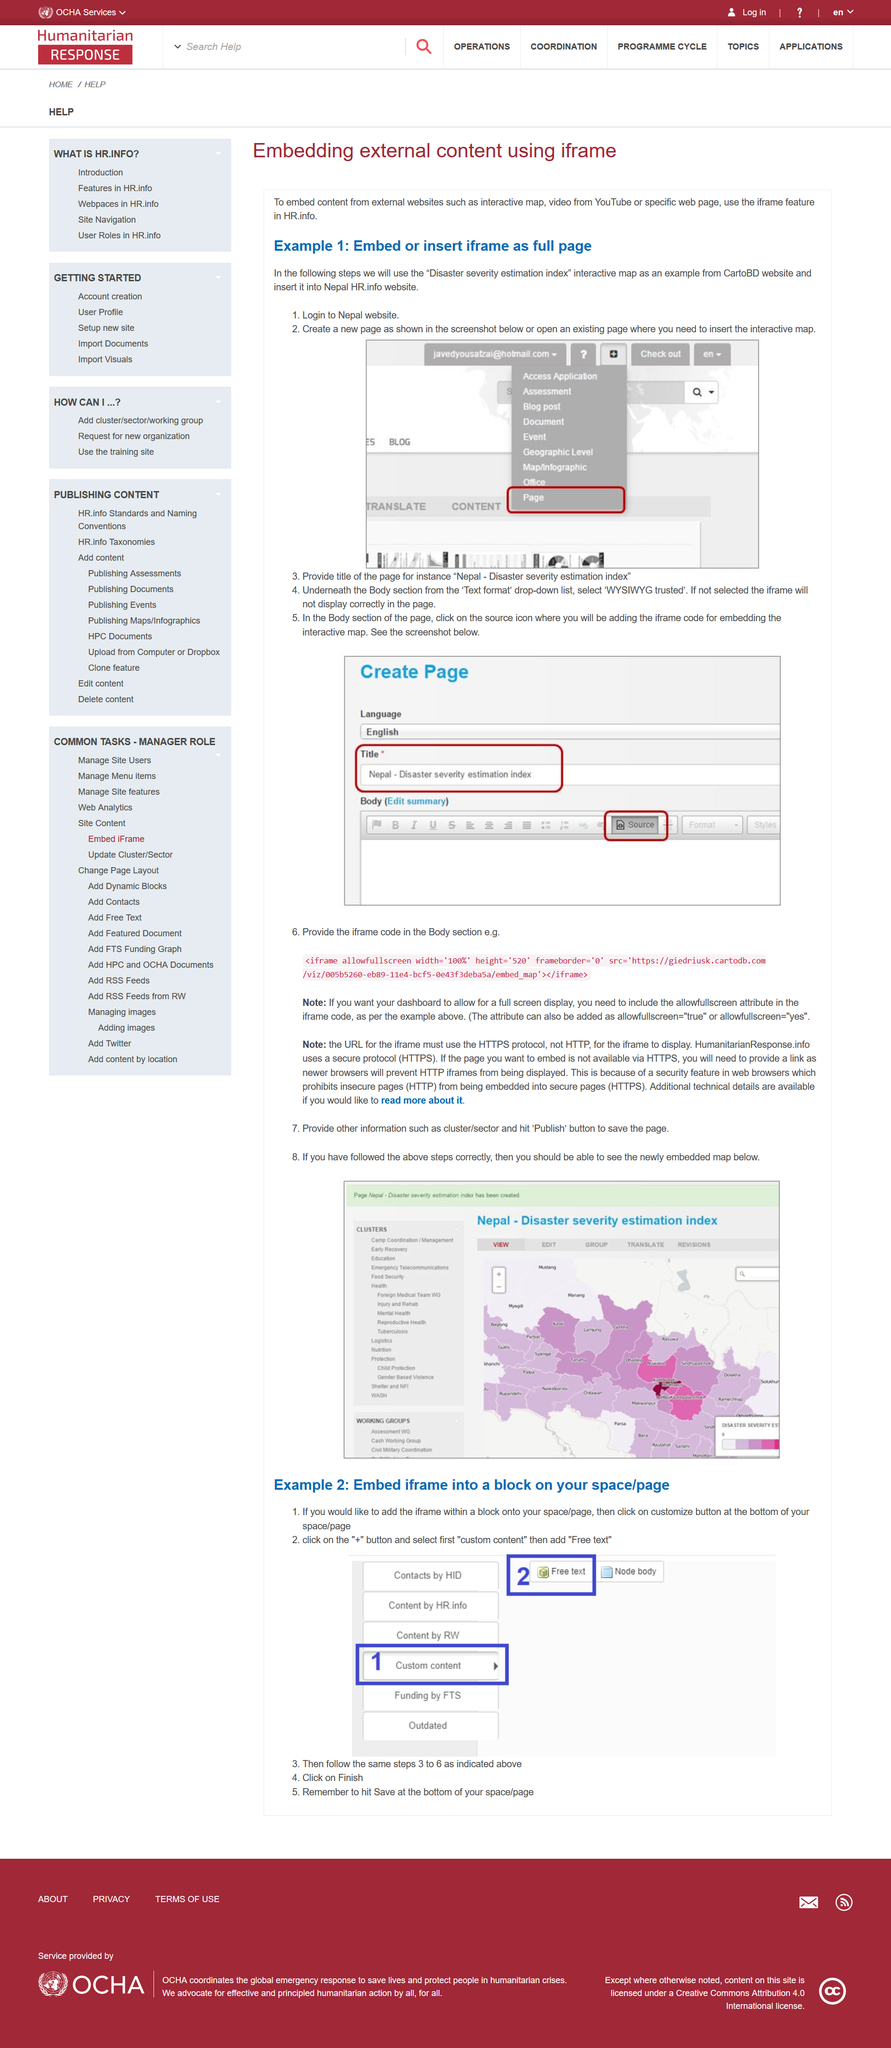Mention a couple of crucial points in this snapshot. To display the dashboard in full screen, include the "allowfullscreen" attribute in the iframe code. The URL for the iframe must be in the form of "https://" to ensure secure communication. It is necessary to click the 'publish' button in order to save the current page. Yes, it is possible to embed or insert an iframe as a full page. The page title is added in a specific location in the editor, and the location of the title box is above the body box. 